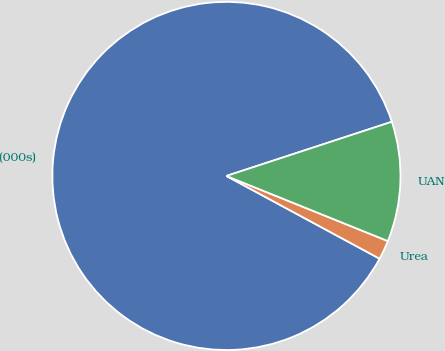<chart> <loc_0><loc_0><loc_500><loc_500><pie_chart><fcel>(000s)<fcel>Urea<fcel>UAN<nl><fcel>87.09%<fcel>1.78%<fcel>11.14%<nl></chart> 